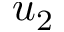Convert formula to latex. <formula><loc_0><loc_0><loc_500><loc_500>u _ { 2 }</formula> 